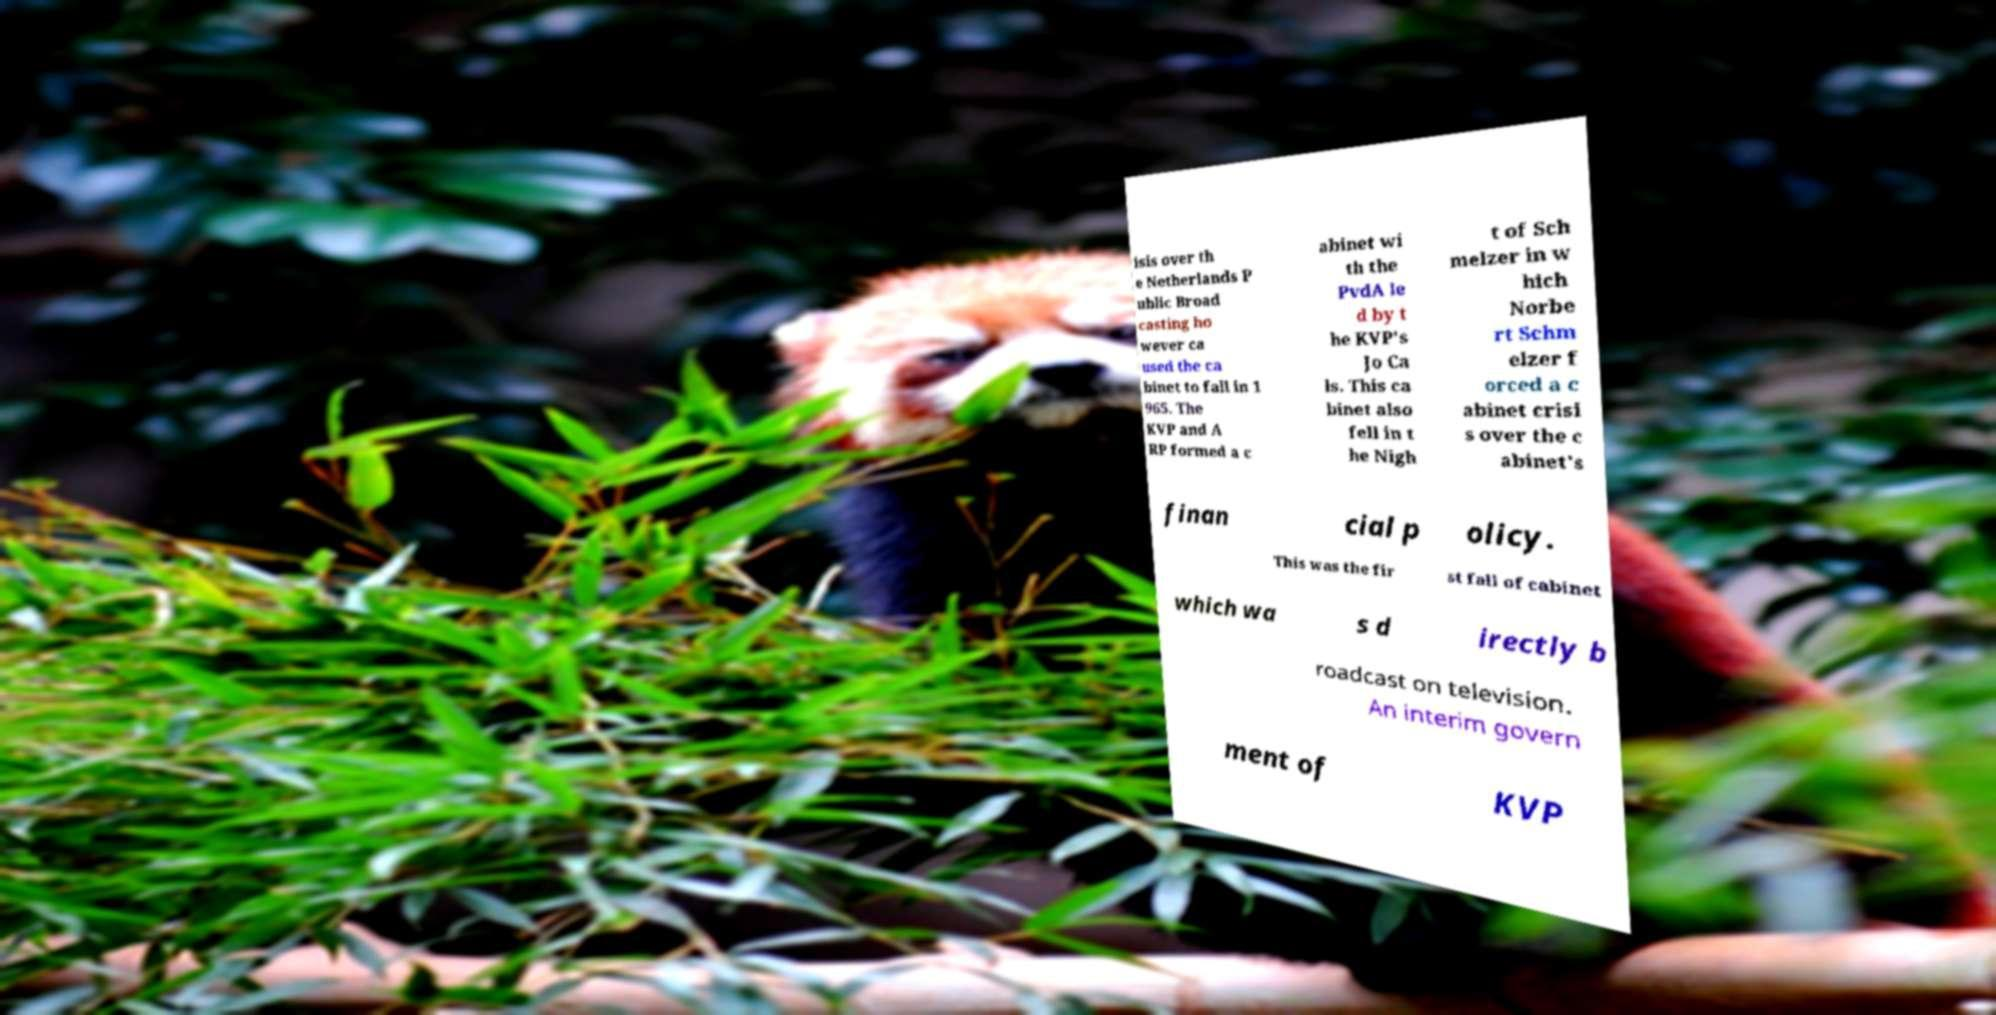For documentation purposes, I need the text within this image transcribed. Could you provide that? isis over th e Netherlands P ublic Broad casting ho wever ca used the ca binet to fall in 1 965. The KVP and A RP formed a c abinet wi th the PvdA le d by t he KVP's Jo Ca ls. This ca binet also fell in t he Nigh t of Sch melzer in w hich Norbe rt Schm elzer f orced a c abinet crisi s over the c abinet's finan cial p olicy. This was the fir st fall of cabinet which wa s d irectly b roadcast on television. An interim govern ment of KVP 